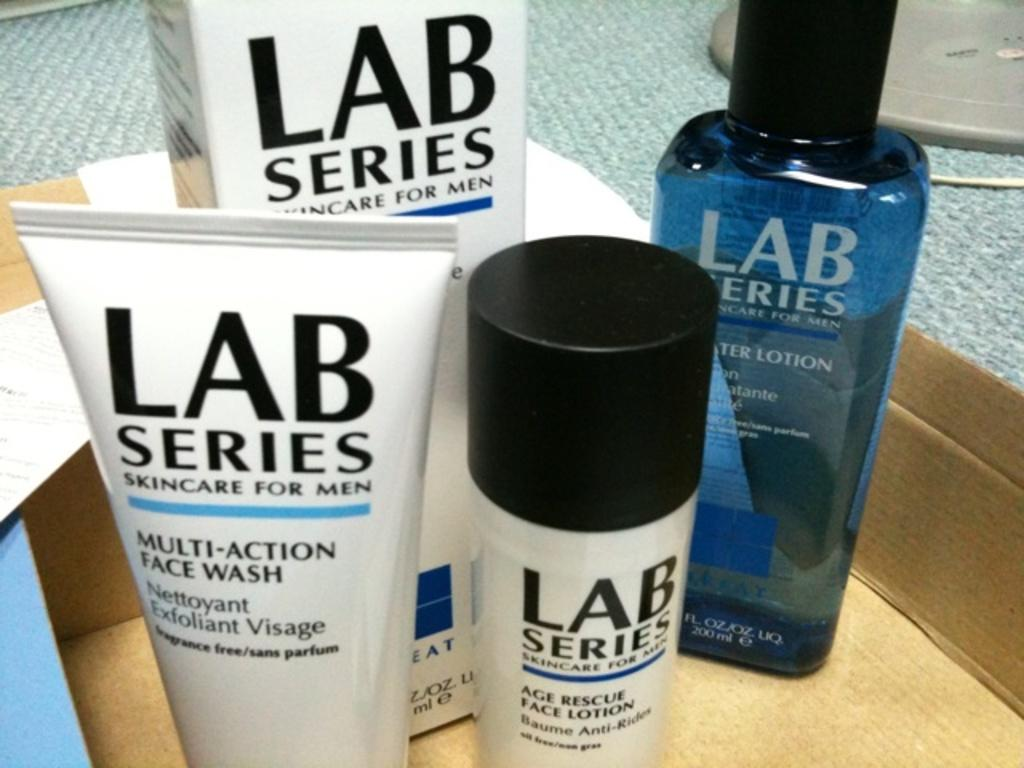Provide a one-sentence caption for the provided image. a set of skin care products with the name Lab series. 